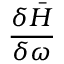Convert formula to latex. <formula><loc_0><loc_0><loc_500><loc_500>\frac { \delta \bar { H } } { \delta \omega }</formula> 